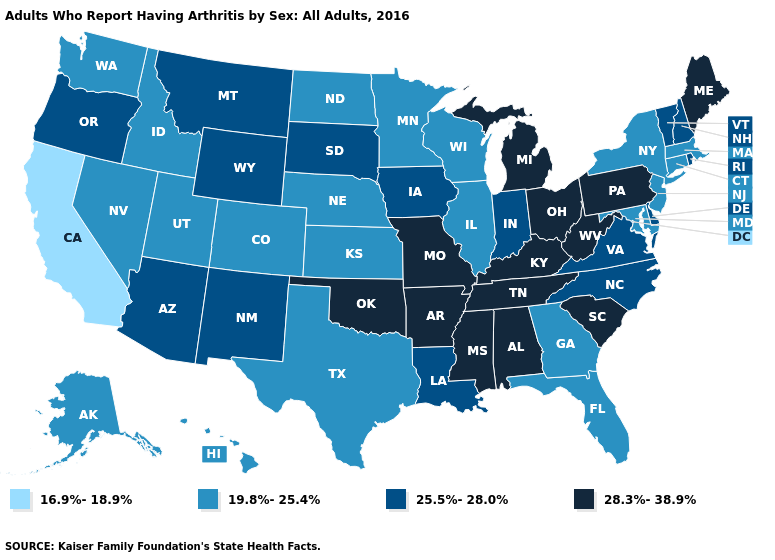Name the states that have a value in the range 19.8%-25.4%?
Give a very brief answer. Alaska, Colorado, Connecticut, Florida, Georgia, Hawaii, Idaho, Illinois, Kansas, Maryland, Massachusetts, Minnesota, Nebraska, Nevada, New Jersey, New York, North Dakota, Texas, Utah, Washington, Wisconsin. What is the lowest value in the Northeast?
Short answer required. 19.8%-25.4%. Among the states that border Idaho , which have the highest value?
Give a very brief answer. Montana, Oregon, Wyoming. Does Oregon have a higher value than Michigan?
Short answer required. No. What is the value of Pennsylvania?
Quick response, please. 28.3%-38.9%. What is the value of Minnesota?
Be succinct. 19.8%-25.4%. How many symbols are there in the legend?
Write a very short answer. 4. What is the lowest value in the South?
Keep it brief. 19.8%-25.4%. Does Oregon have the same value as South Carolina?
Give a very brief answer. No. Name the states that have a value in the range 19.8%-25.4%?
Keep it brief. Alaska, Colorado, Connecticut, Florida, Georgia, Hawaii, Idaho, Illinois, Kansas, Maryland, Massachusetts, Minnesota, Nebraska, Nevada, New Jersey, New York, North Dakota, Texas, Utah, Washington, Wisconsin. Does Wyoming have the highest value in the West?
Quick response, please. Yes. What is the value of Montana?
Write a very short answer. 25.5%-28.0%. Among the states that border Tennessee , which have the lowest value?
Answer briefly. Georgia. What is the value of Missouri?
Quick response, please. 28.3%-38.9%. What is the value of Hawaii?
Keep it brief. 19.8%-25.4%. 